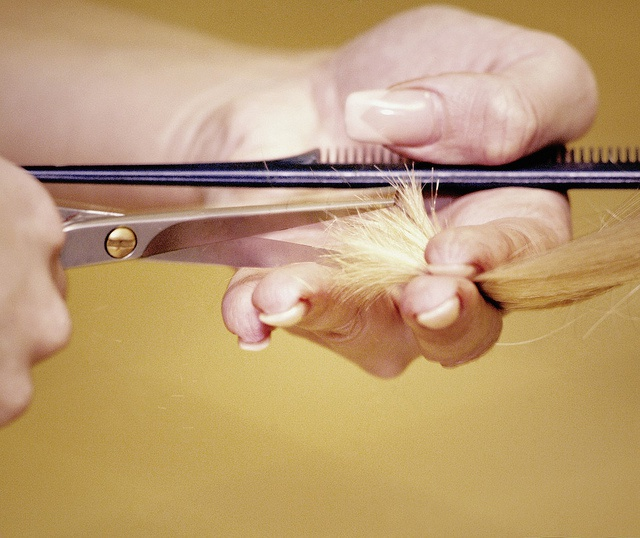Describe the objects in this image and their specific colors. I can see people in tan and lightgray tones and scissors in tan and brown tones in this image. 